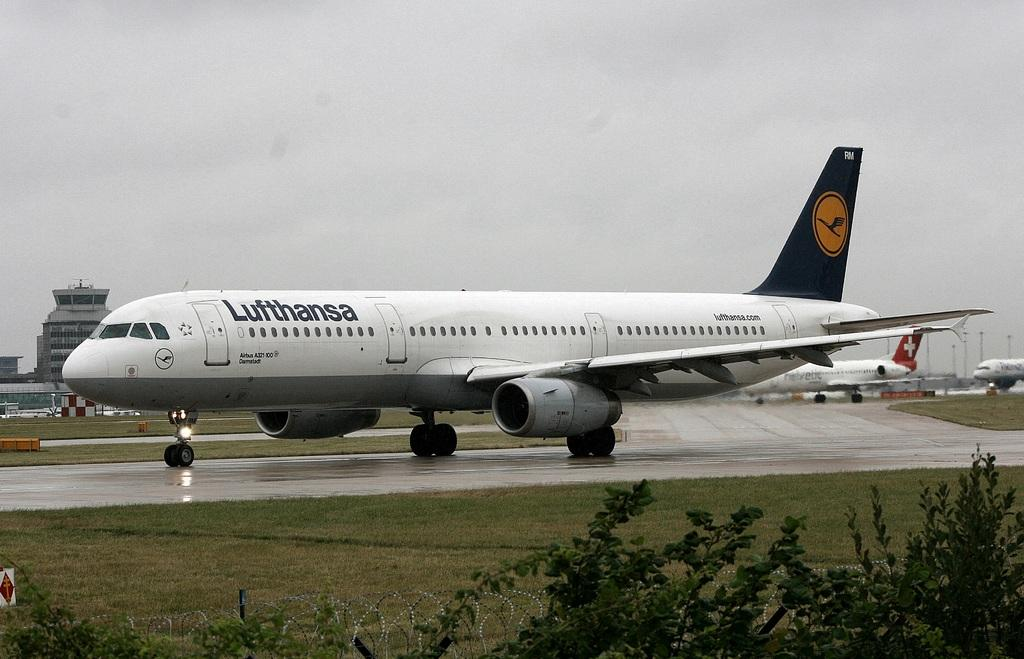<image>
Create a compact narrative representing the image presented. a plane that has Lufthansa written on the side of it 